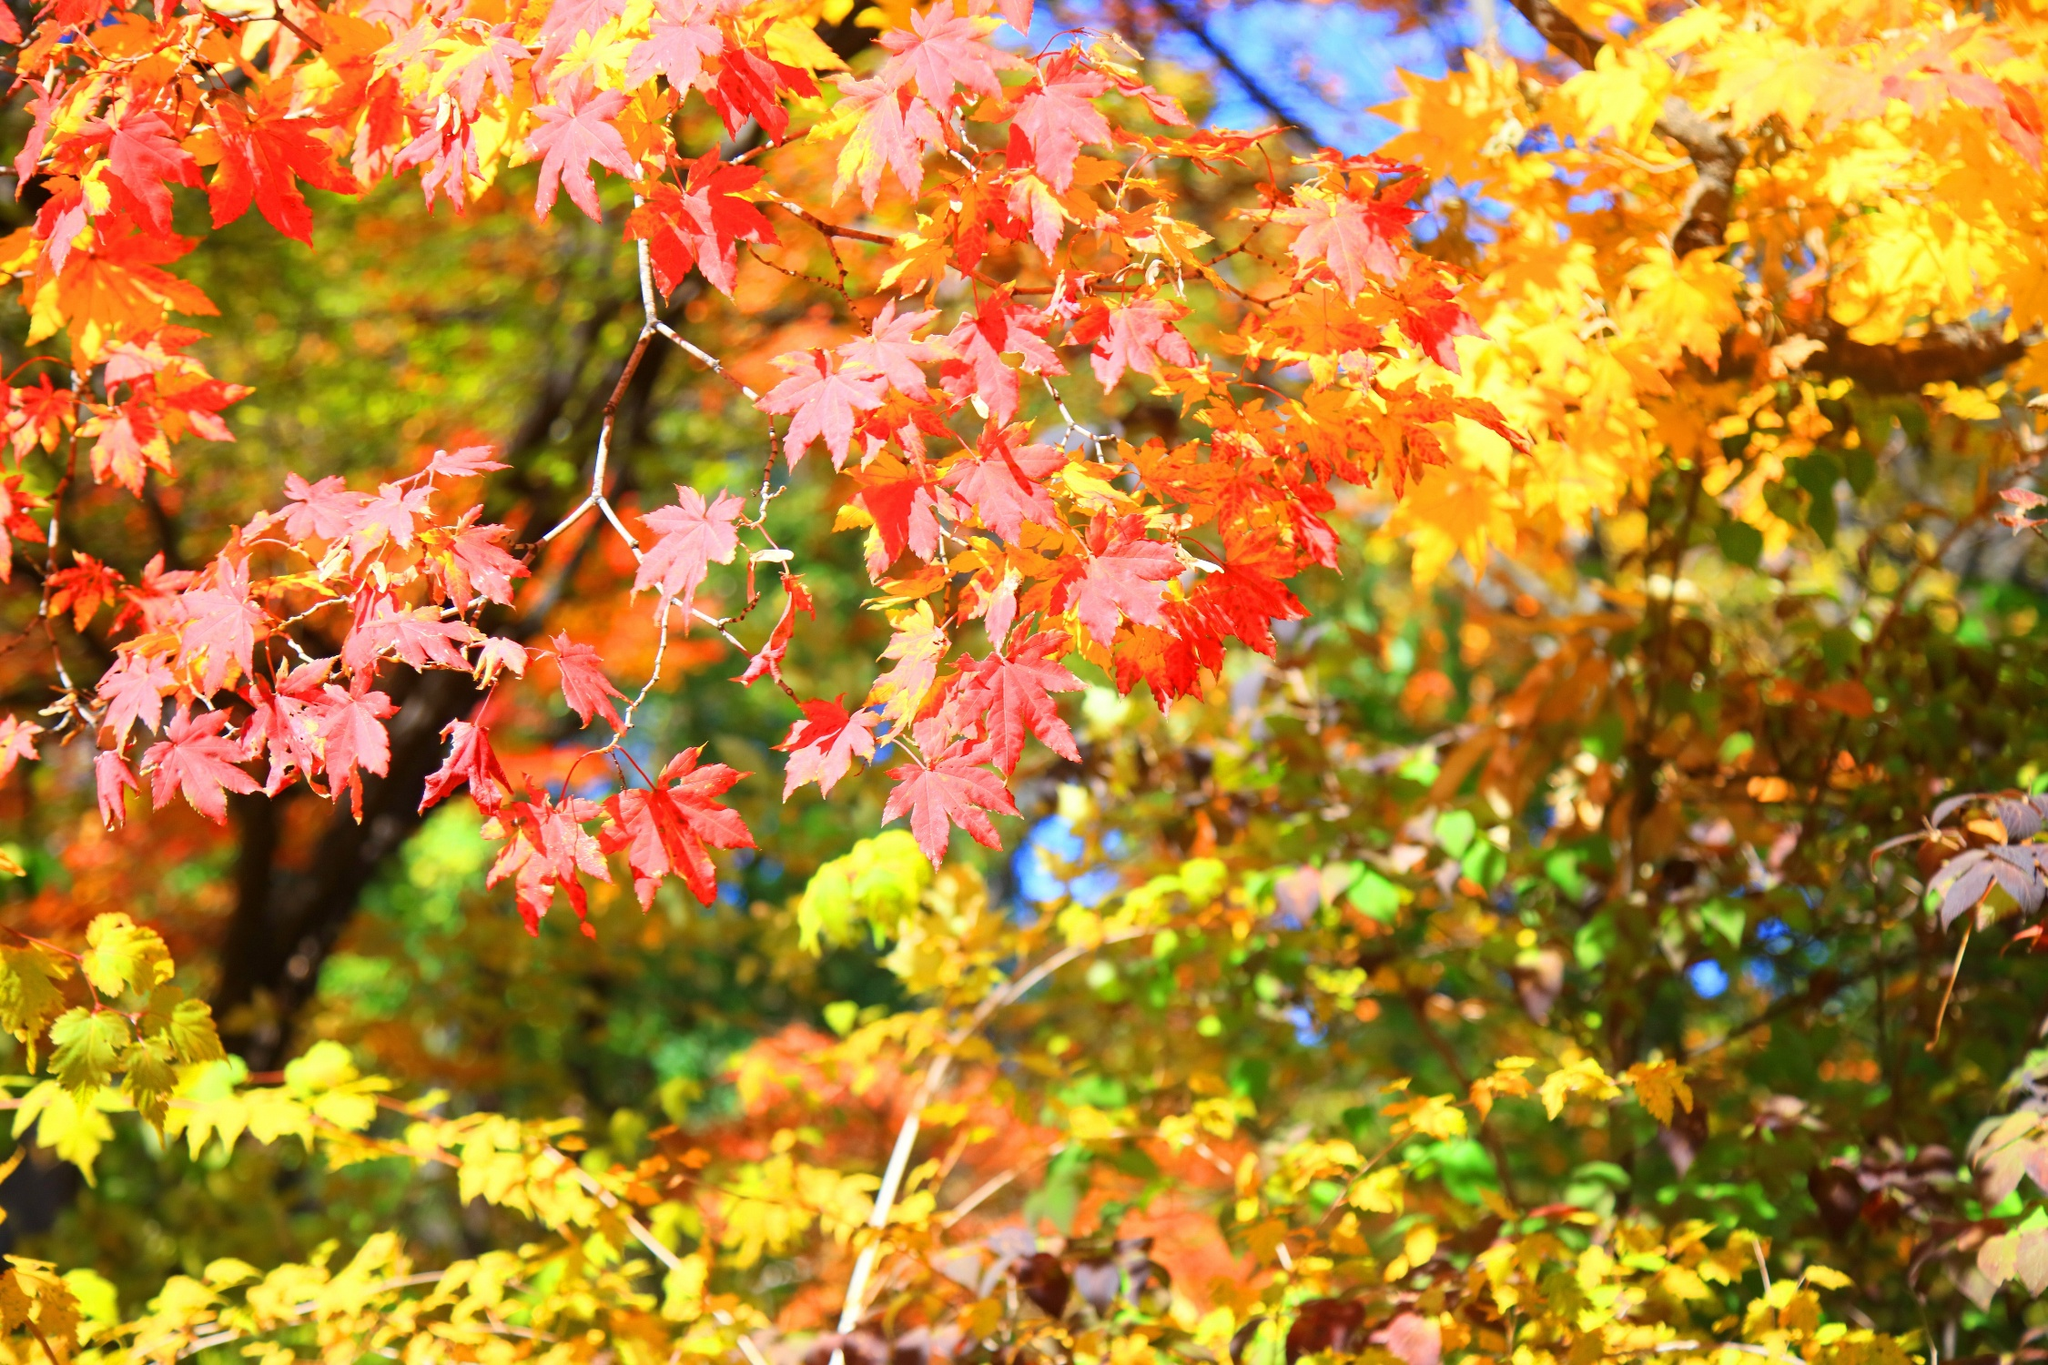Imagine this scene is part of a fantasy world. What kind of story could unfold here? In a mystical forest where the seasons are governed by ancient spirits, this tree is the guardian of autumn. Each leaf holds a piece of the magic that keeps the forest in a state of perpetual balance. As the sun sets, a soft glow emanates from the leaves, illuminating secret pathways known only to the woodland creatures and adventurous souls. The tree whispers ancient tales of the forest, calling forth those who seek wisdom and serenity. What challenges might a character face in this enchanted autumn forest? A character in this enchanted autumn forest might encounter a myriad of challenges. They could face puzzles that require interpreting the tree's whispers or navigating pathless mazes formed by the whispering trees. Magical creatures like mischievous pixies might play tricks on them, and they could need to solve riddles to continue their journey. Additionally, the character might have to earn the trust of the forest spirits by performing acts of kindness or bravery, all while dealing with the unpredictable shifts in the environment that challenge their will and wisdom. 